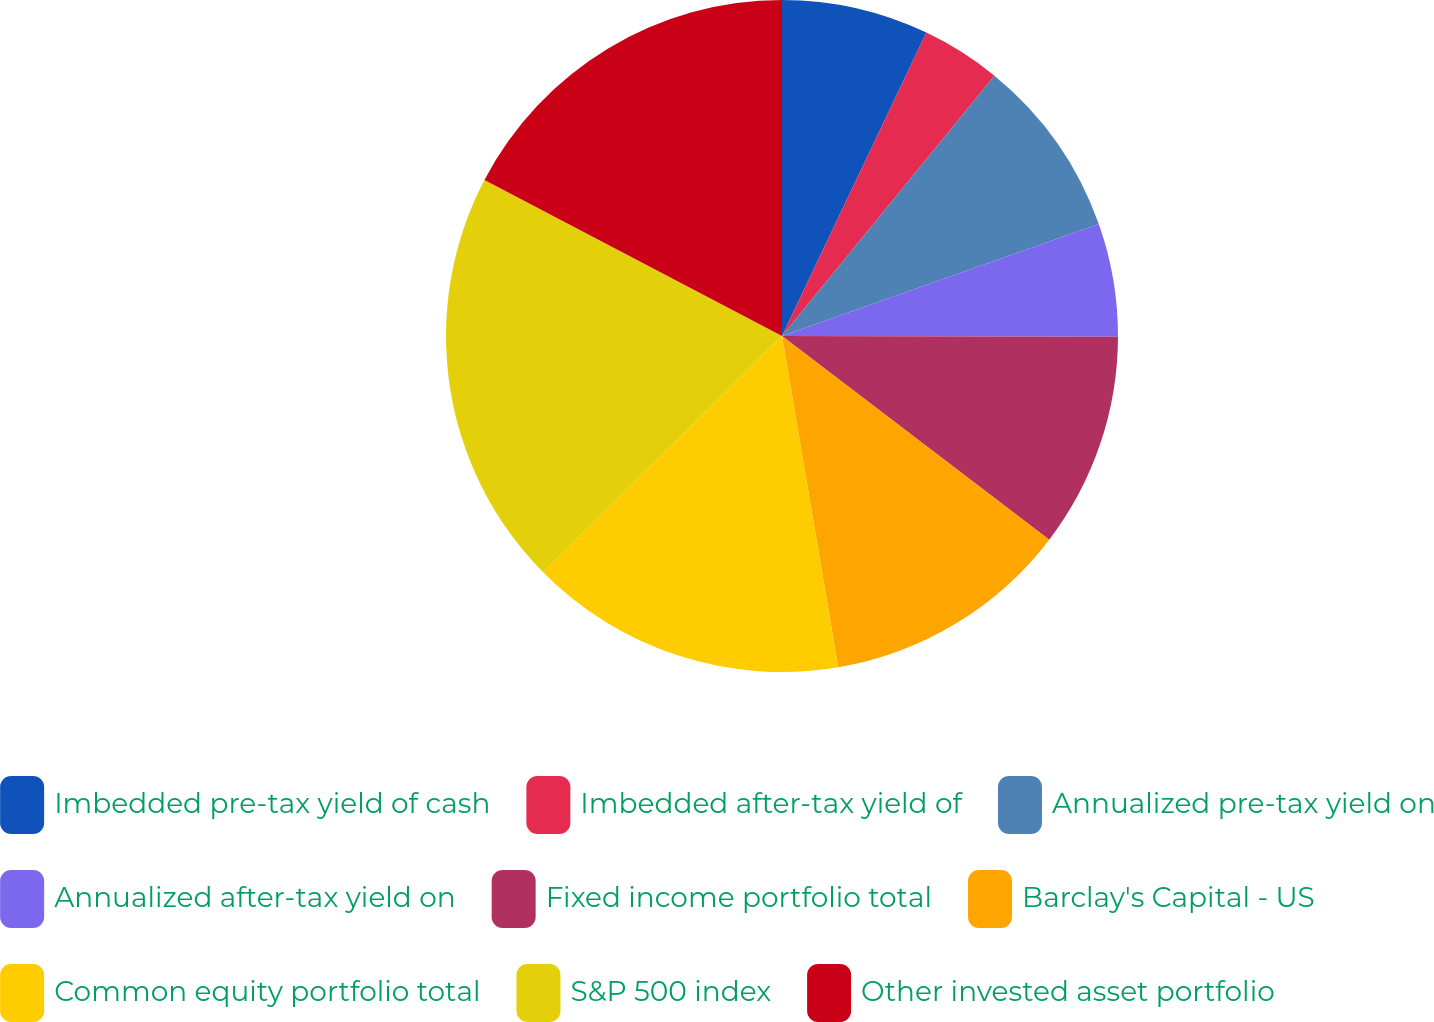Convert chart. <chart><loc_0><loc_0><loc_500><loc_500><pie_chart><fcel>Imbedded pre-tax yield of cash<fcel>Imbedded after-tax yield of<fcel>Annualized pre-tax yield on<fcel>Annualized after-tax yield on<fcel>Fixed income portfolio total<fcel>Barclay's Capital - US<fcel>Common equity portfolio total<fcel>S&P 500 index<fcel>Other invested asset portfolio<nl><fcel>7.07%<fcel>3.82%<fcel>8.7%<fcel>5.44%<fcel>10.33%<fcel>11.96%<fcel>15.26%<fcel>20.1%<fcel>17.31%<nl></chart> 